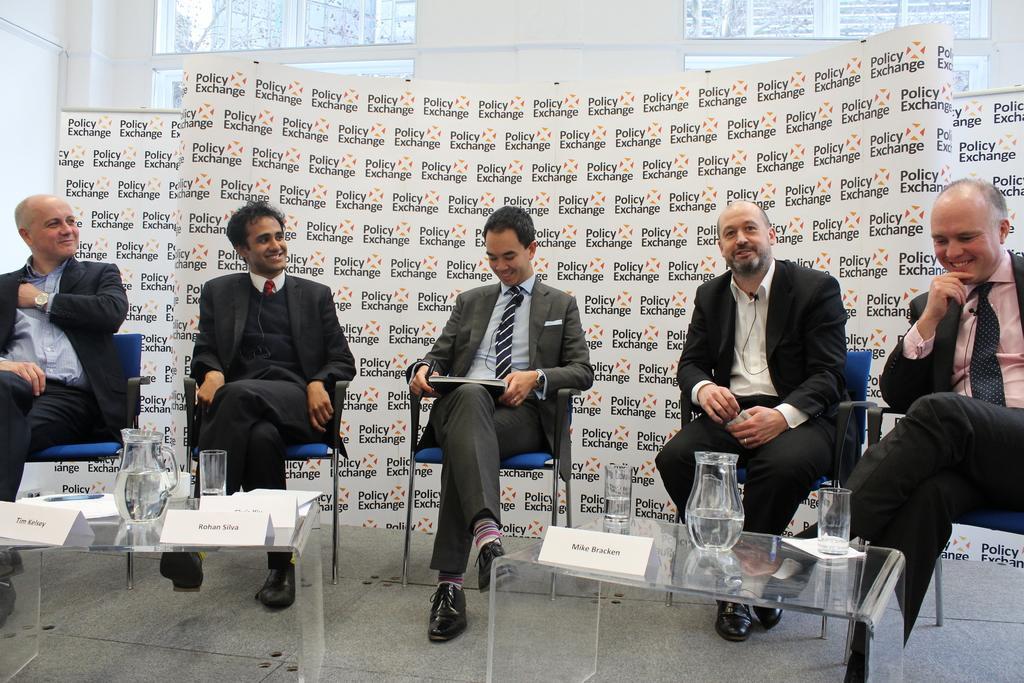Describe this image in one or two sentences. In this image I can see group of people sitting. In front the person is wearing gray blazer and holding a book and a pen. In front I can see few glasses, jugs on the glass table, background the wall is in white color. 